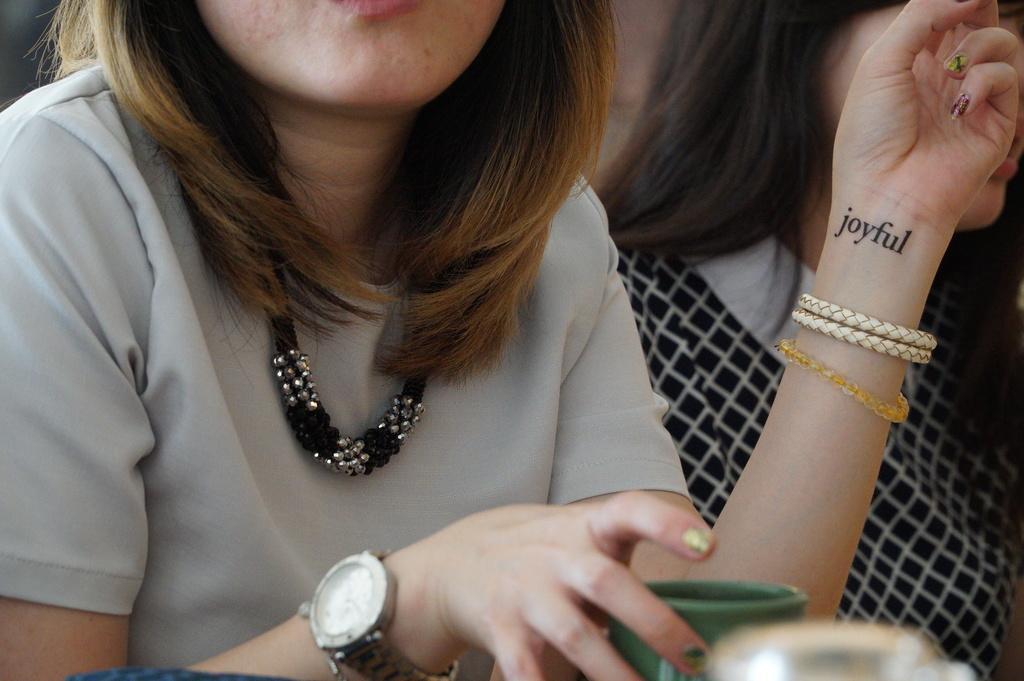In one or two sentences, can you explain what this image depicts? Here a woman is holding cup in the hand, wearing watch and clothes. 